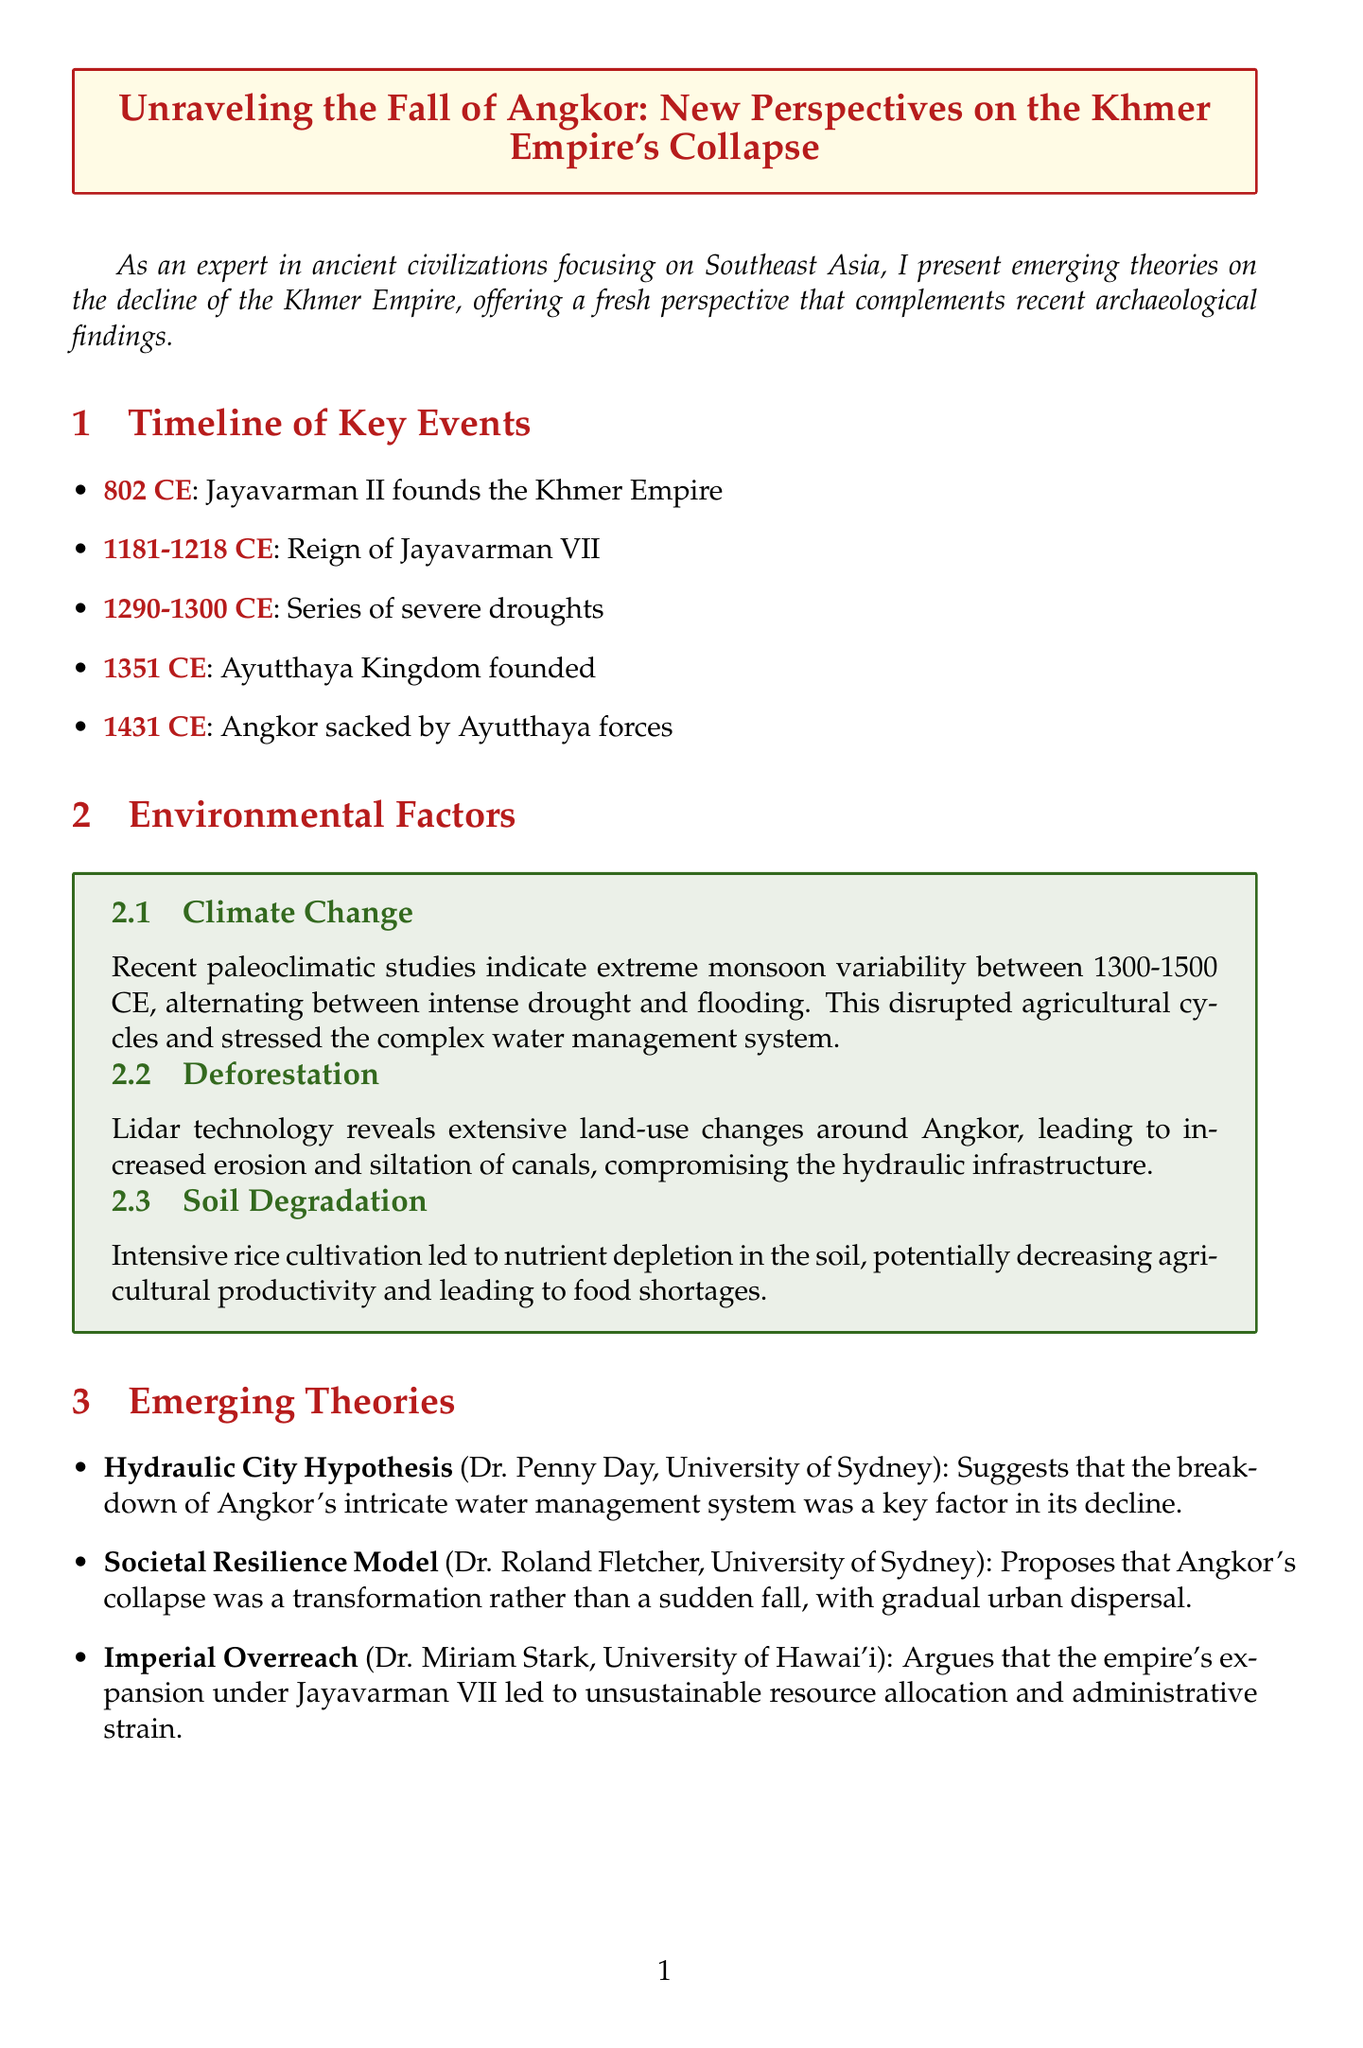What year was the Khmer Empire founded? The document states that the Khmer Empire was founded in 802 CE.
Answer: 802 CE Who reigned from 1181 to 1218 CE? The timeline mentions Jayavarman VII as the ruler during this period.
Answer: Jayavarman VII What environmental factor disrupted agricultural cycles? The document highlights climate change as a factor that disrupted agricultural cycles.
Answer: Climate Change What does the Hydraulic City Hypothesis suggest? According to the document, it suggests the breakdown of Angkor's water management was a key factor in its decline.
Answer: Breakdown of water management In what year did the Angkor fall? The document notes that Angkor was sacked in 1431 CE.
Answer: 1431 CE Who proposed the Societal Resilience Model? The document attributes the Societal Resilience Model to Dr. Roland Fletcher.
Answer: Dr. Roland Fletcher Which event is associated with the founding of the Ayutthaya Kingdom? The timeline indicates that the Ayutthaya Kingdom was founded in 1351 CE.
Answer: 1351 CE What caused soil degradation in Angkor? The document states that intensive rice cultivation led to nutrient depletion in the soil.
Answer: Intensive rice cultivation What is the main conclusion drawn in the document? The conclusion suggests that the collapse involved complex environmental, social, and political factors.
Answer: Complex interplay of factors 